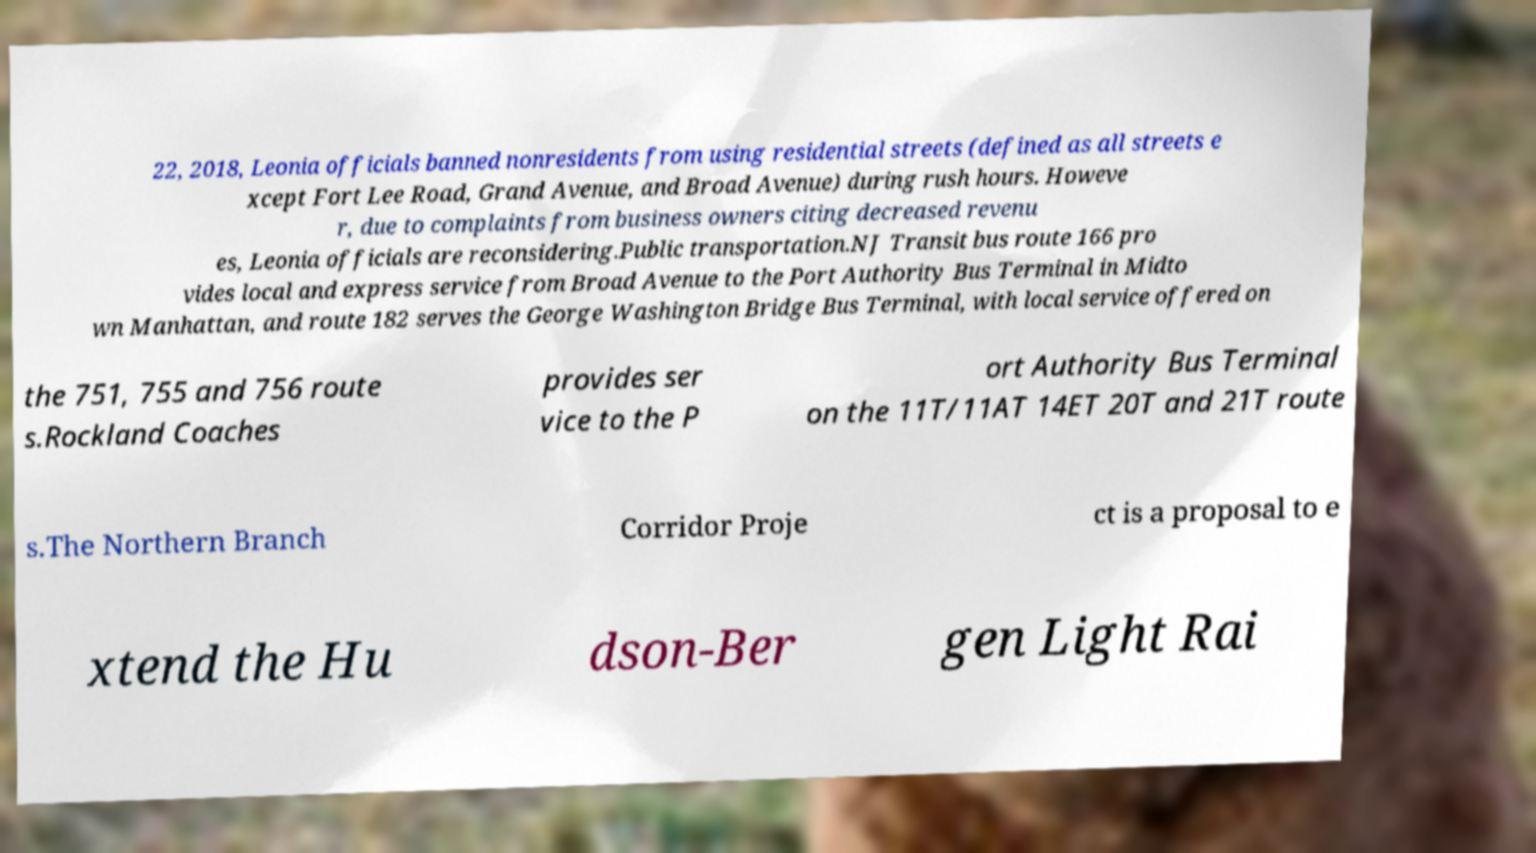Could you extract and type out the text from this image? 22, 2018, Leonia officials banned nonresidents from using residential streets (defined as all streets e xcept Fort Lee Road, Grand Avenue, and Broad Avenue) during rush hours. Howeve r, due to complaints from business owners citing decreased revenu es, Leonia officials are reconsidering.Public transportation.NJ Transit bus route 166 pro vides local and express service from Broad Avenue to the Port Authority Bus Terminal in Midto wn Manhattan, and route 182 serves the George Washington Bridge Bus Terminal, with local service offered on the 751, 755 and 756 route s.Rockland Coaches provides ser vice to the P ort Authority Bus Terminal on the 11T/11AT 14ET 20T and 21T route s.The Northern Branch Corridor Proje ct is a proposal to e xtend the Hu dson-Ber gen Light Rai 